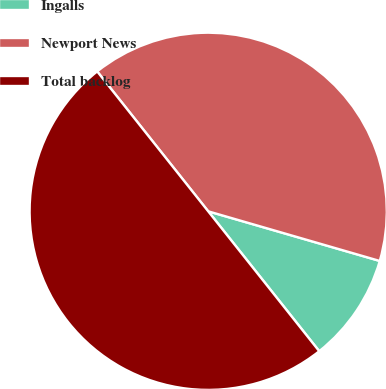<chart> <loc_0><loc_0><loc_500><loc_500><pie_chart><fcel>Ingalls<fcel>Newport News<fcel>Total backlog<nl><fcel>9.84%<fcel>40.16%<fcel>50.0%<nl></chart> 